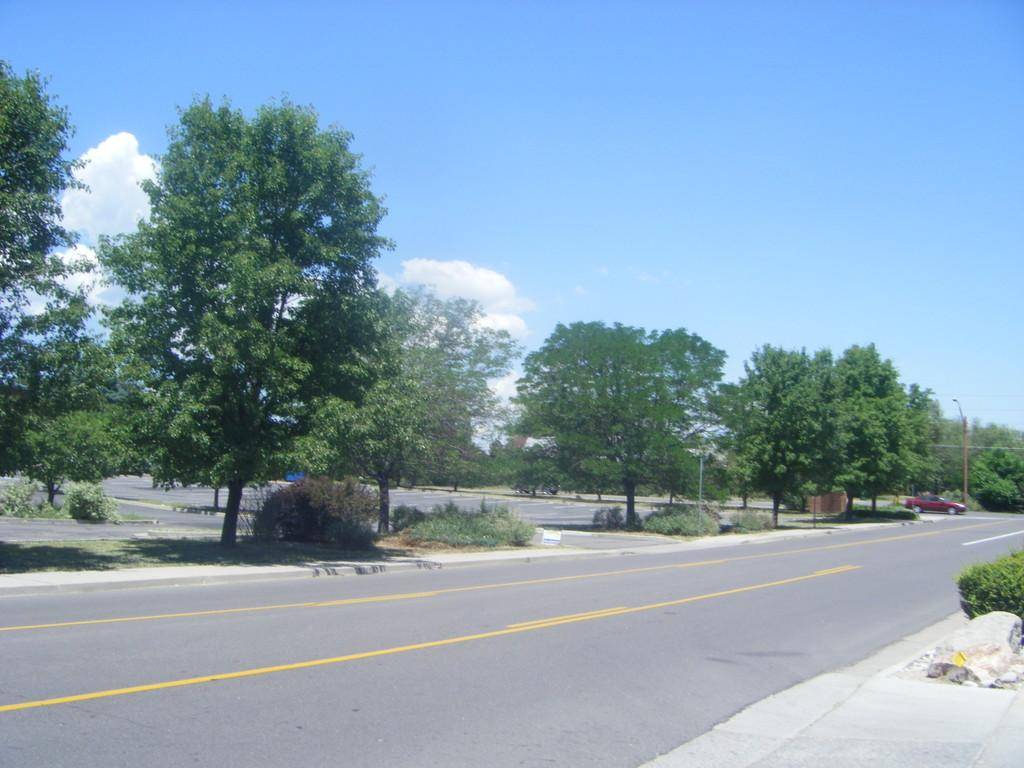What type of vegetation can be seen in the image? There are trees in the image. What part of the natural environment is visible in the image? The sky is visible in the image. What type of transportation is present in the image? There is a car on the road in the image. What structures can be seen in the image? There are poles in the image. What type of rock is being used as a cause for the uncle's celebration in the image? There is no rock, cause, or uncle present in the image. 